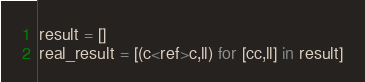<code> <loc_0><loc_0><loc_500><loc_500><_Python_>result = []
real_result = [(c<ref>c,ll) for [cc,ll] in result]</code> 